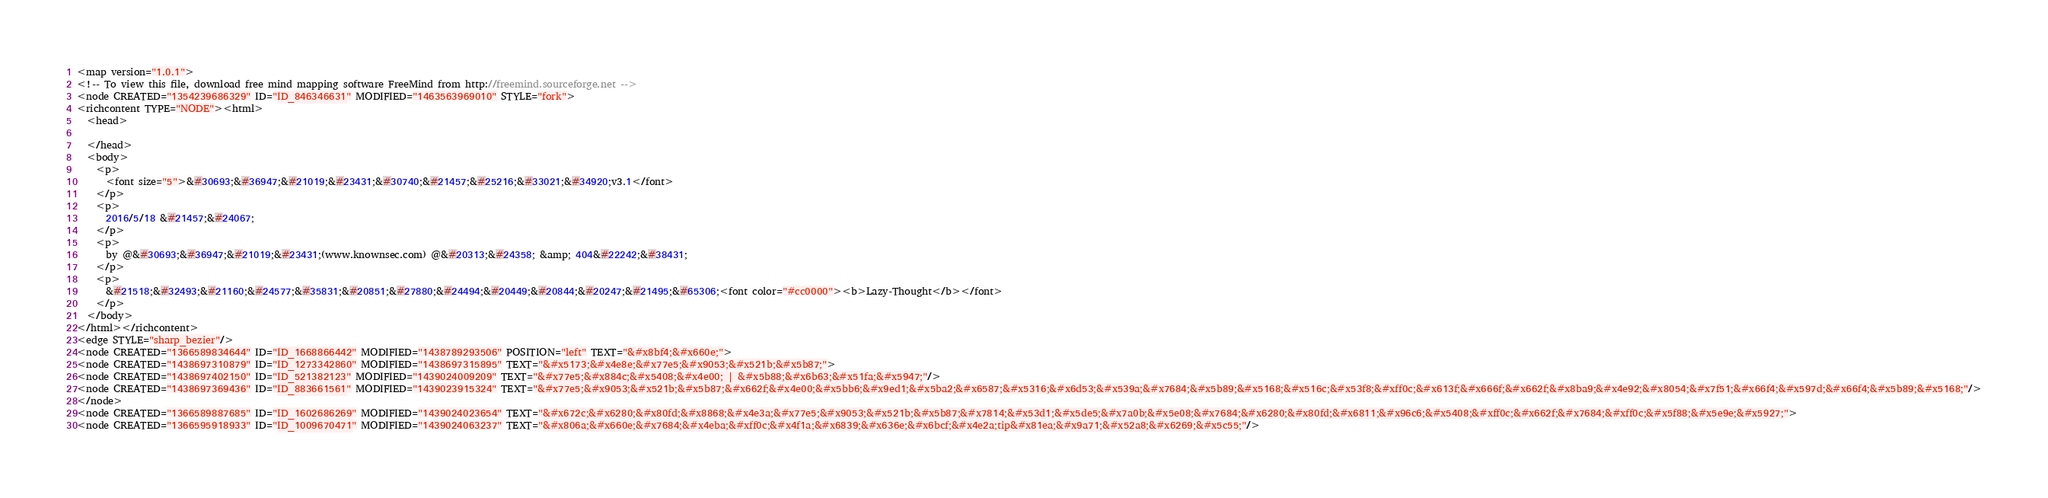Convert code to text. <code><loc_0><loc_0><loc_500><loc_500><_ObjectiveC_><map version="1.0.1">
<!-- To view this file, download free mind mapping software FreeMind from http://freemind.sourceforge.net -->
<node CREATED="1354239686329" ID="ID_846346631" MODIFIED="1463563969010" STYLE="fork">
<richcontent TYPE="NODE"><html>
  <head>
    
  </head>
  <body>
    <p>
      <font size="5">&#30693;&#36947;&#21019;&#23431;&#30740;&#21457;&#25216;&#33021;&#34920;v3.1</font>
    </p>
    <p>
      2016/5/18 &#21457;&#24067;
    </p>
    <p>
      by @&#30693;&#36947;&#21019;&#23431;(www.knownsec.com) @&#20313;&#24358; &amp; 404&#22242;&#38431;
    </p>
    <p>
      &#21518;&#32493;&#21160;&#24577;&#35831;&#20851;&#27880;&#24494;&#20449;&#20844;&#20247;&#21495;&#65306;<font color="#cc0000"><b>Lazy-Thought</b></font>
    </p>
  </body>
</html></richcontent>
<edge STYLE="sharp_bezier"/>
<node CREATED="1366589834644" ID="ID_1668866442" MODIFIED="1438789293506" POSITION="left" TEXT="&#x8bf4;&#x660e;">
<node CREATED="1438697310879" ID="ID_1273342860" MODIFIED="1438697315895" TEXT="&#x5173;&#x4e8e;&#x77e5;&#x9053;&#x521b;&#x5b87;">
<node CREATED="1438697402150" ID="ID_521382123" MODIFIED="1439024009209" TEXT="&#x77e5;&#x884c;&#x5408;&#x4e00; | &#x5b88;&#x6b63;&#x51fa;&#x5947;"/>
<node CREATED="1438697369436" ID="ID_883661561" MODIFIED="1439023915324" TEXT="&#x77e5;&#x9053;&#x521b;&#x5b87;&#x662f;&#x4e00;&#x5bb6;&#x9ed1;&#x5ba2;&#x6587;&#x5316;&#x6d53;&#x539a;&#x7684;&#x5b89;&#x5168;&#x516c;&#x53f8;&#xff0c;&#x613f;&#x666f;&#x662f;&#x8ba9;&#x4e92;&#x8054;&#x7f51;&#x66f4;&#x597d;&#x66f4;&#x5b89;&#x5168;"/>
</node>
<node CREATED="1366589887685" ID="ID_1602686269" MODIFIED="1439024023654" TEXT="&#x672c;&#x6280;&#x80fd;&#x8868;&#x4e3a;&#x77e5;&#x9053;&#x521b;&#x5b87;&#x7814;&#x53d1;&#x5de5;&#x7a0b;&#x5e08;&#x7684;&#x6280;&#x80fd;&#x6811;&#x96c6;&#x5408;&#xff0c;&#x662f;&#x7684;&#xff0c;&#x5f88;&#x5e9e;&#x5927;">
<node CREATED="1366595918933" ID="ID_1009670471" MODIFIED="1439024063237" TEXT="&#x806a;&#x660e;&#x7684;&#x4eba;&#xff0c;&#x4f1a;&#x6839;&#x636e;&#x6bcf;&#x4e2a;tip&#x81ea;&#x9a71;&#x52a8;&#x6269;&#x5c55;"/></code> 